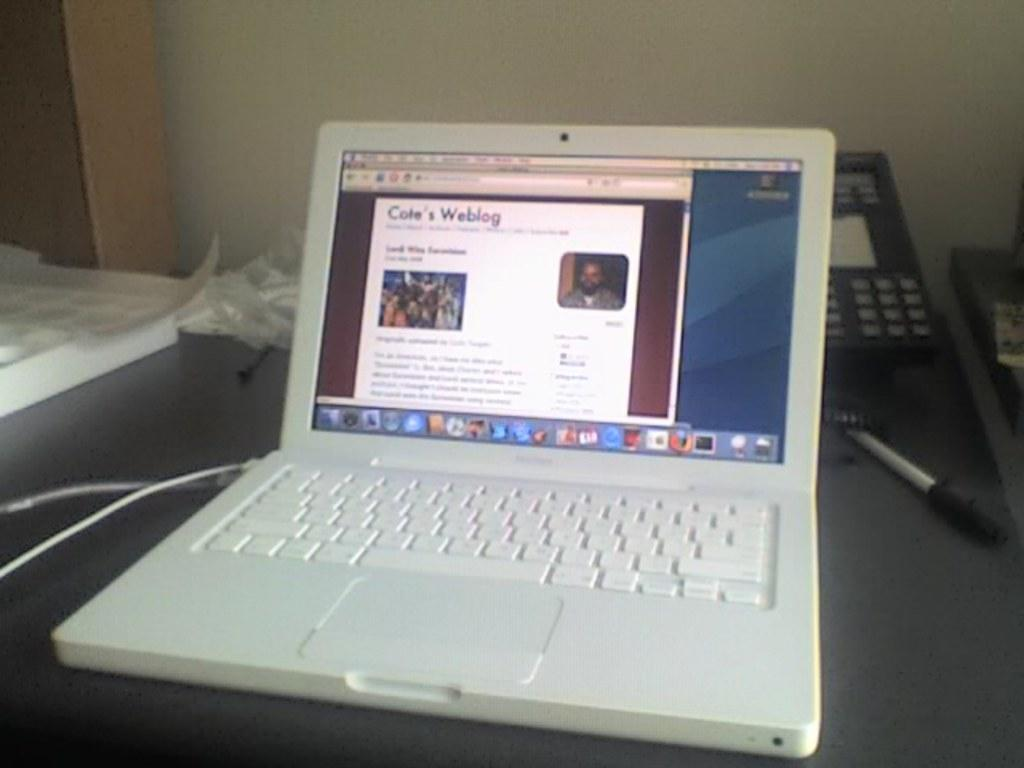<image>
Present a compact description of the photo's key features. A laptop computer is displayed with a keyboard and a screen   that requires a key or a number to be selected for retrieving information or data. 